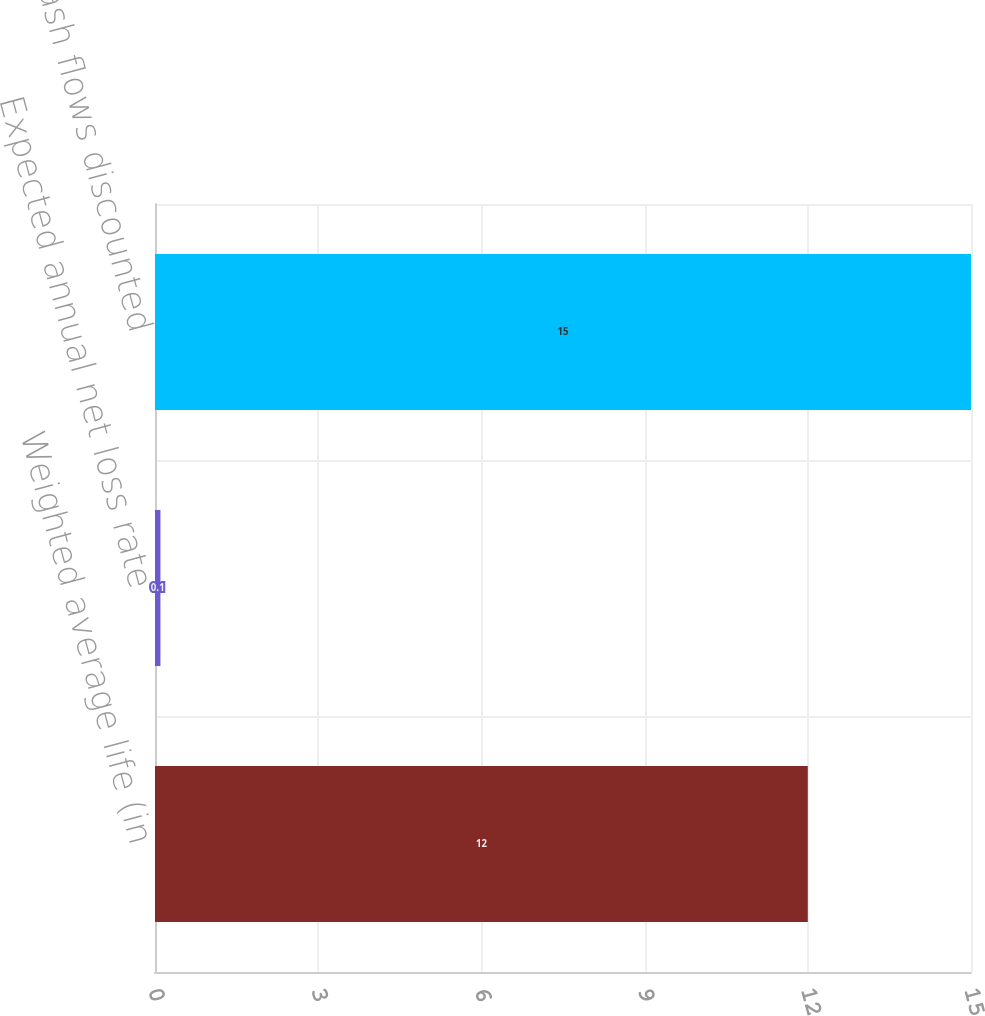Convert chart to OTSL. <chart><loc_0><loc_0><loc_500><loc_500><bar_chart><fcel>Weighted average life (in<fcel>Expected annual net loss rate<fcel>Residual cash flows discounted<nl><fcel>12<fcel>0.1<fcel>15<nl></chart> 